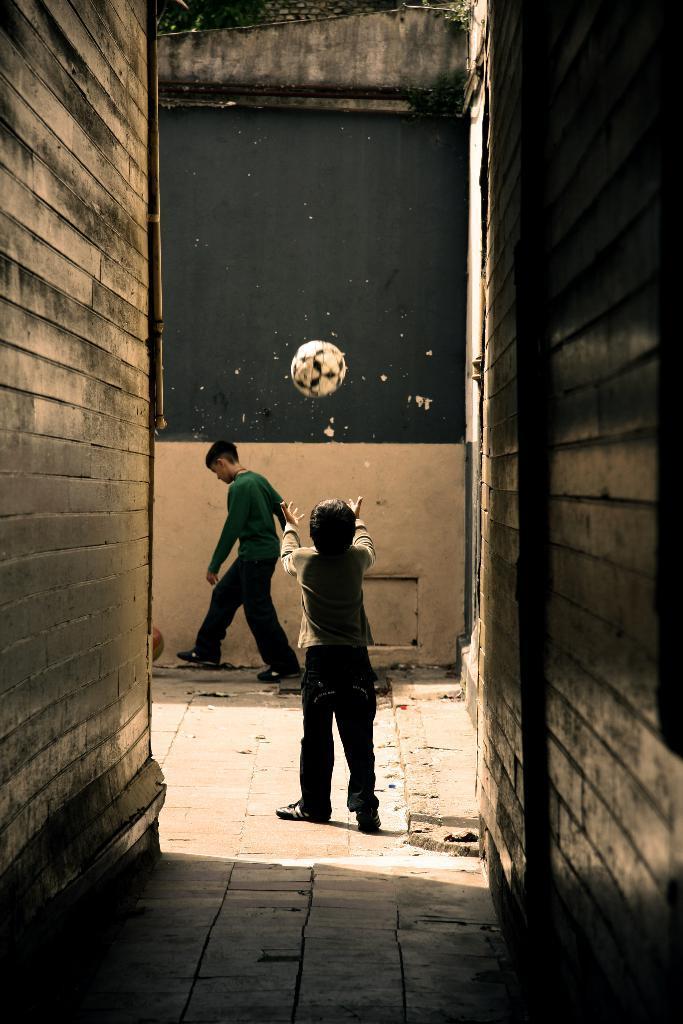In one or two sentences, can you explain what this image depicts? In this image there are two kids standing at middle of this image and there is a ball in white color is at top of this image and there is a sky in the background. There is a wall at left side of this image and right side of this image as well ,and there is a floor at bottom of this image. 